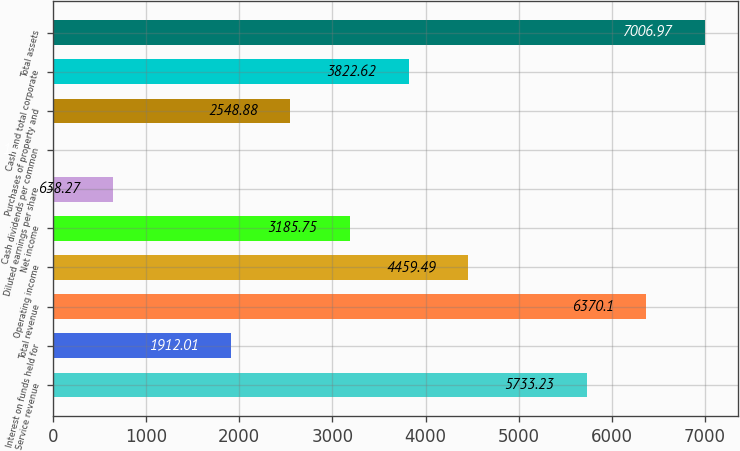Convert chart. <chart><loc_0><loc_0><loc_500><loc_500><bar_chart><fcel>Service revenue<fcel>Interest on funds held for<fcel>Total revenue<fcel>Operating income<fcel>Net income<fcel>Diluted earnings per share<fcel>Cash dividends per common<fcel>Purchases of property and<fcel>Cash and total corporate<fcel>Total assets<nl><fcel>5733.23<fcel>1912.01<fcel>6370.1<fcel>4459.49<fcel>3185.75<fcel>638.27<fcel>1.4<fcel>2548.88<fcel>3822.62<fcel>7006.97<nl></chart> 